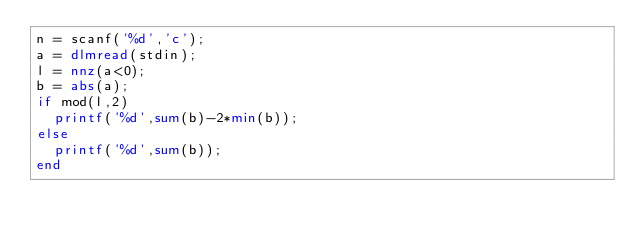Convert code to text. <code><loc_0><loc_0><loc_500><loc_500><_Octave_>n = scanf('%d','c');
a = dlmread(stdin);
l = nnz(a<0);
b = abs(a);
if mod(l,2)
	printf('%d',sum(b)-2*min(b));
else
	printf('%d',sum(b));
end

</code> 